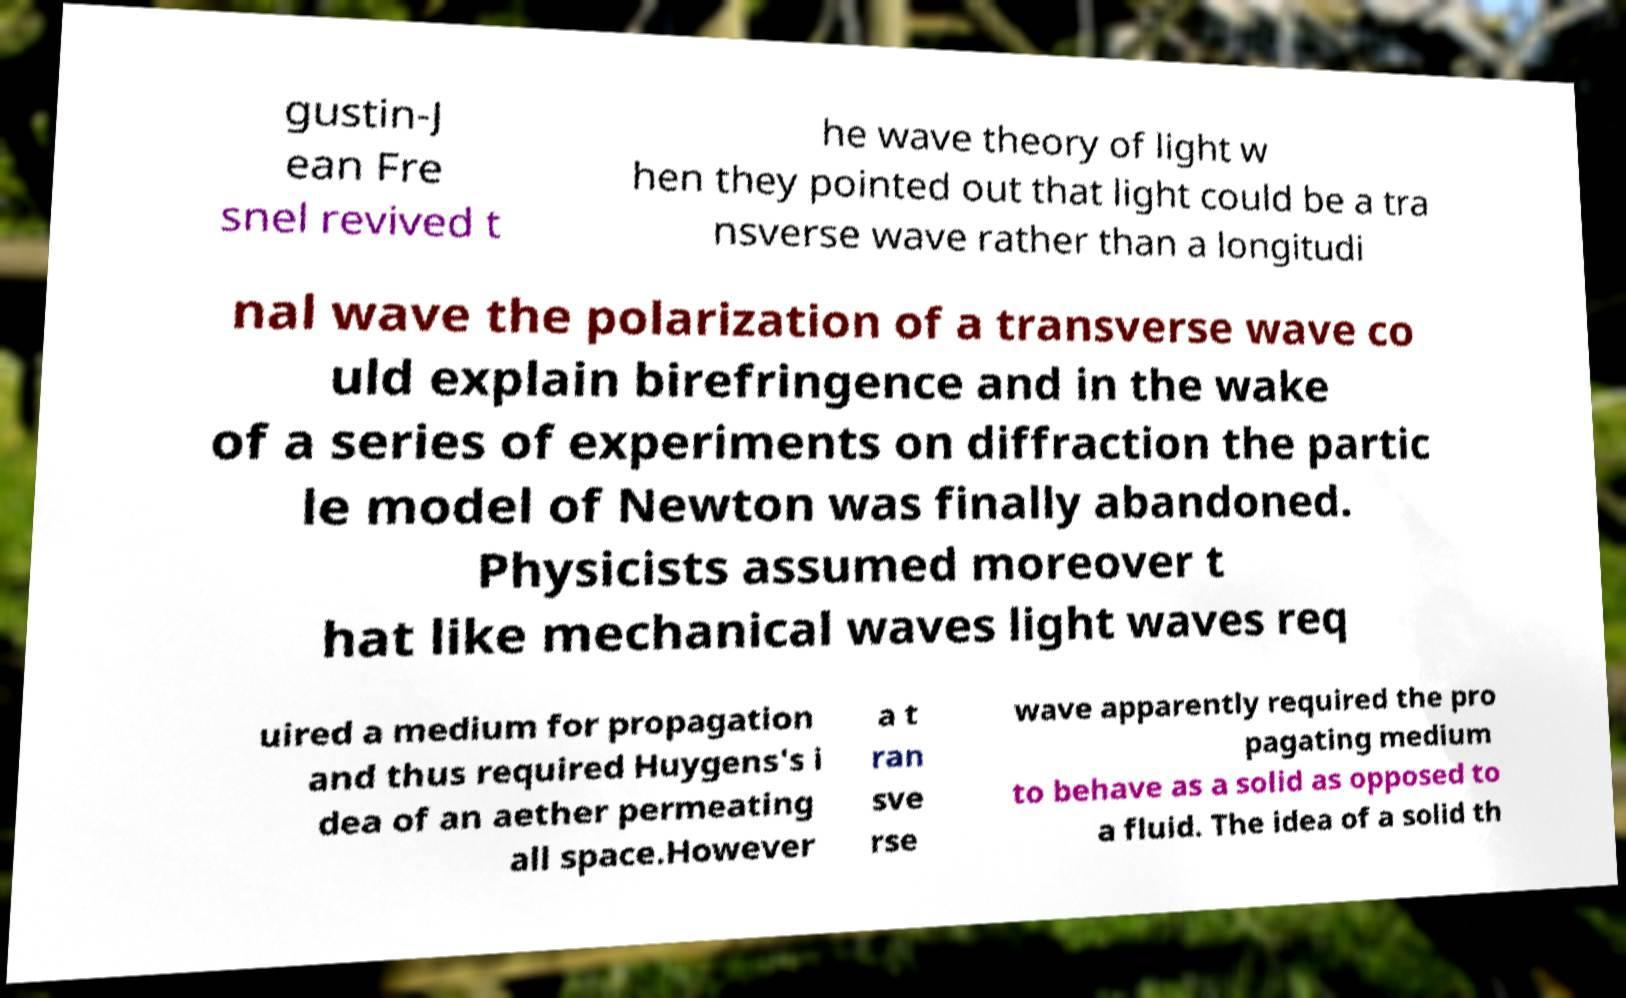I need the written content from this picture converted into text. Can you do that? gustin-J ean Fre snel revived t he wave theory of light w hen they pointed out that light could be a tra nsverse wave rather than a longitudi nal wave the polarization of a transverse wave co uld explain birefringence and in the wake of a series of experiments on diffraction the partic le model of Newton was finally abandoned. Physicists assumed moreover t hat like mechanical waves light waves req uired a medium for propagation and thus required Huygens's i dea of an aether permeating all space.However a t ran sve rse wave apparently required the pro pagating medium to behave as a solid as opposed to a fluid. The idea of a solid th 